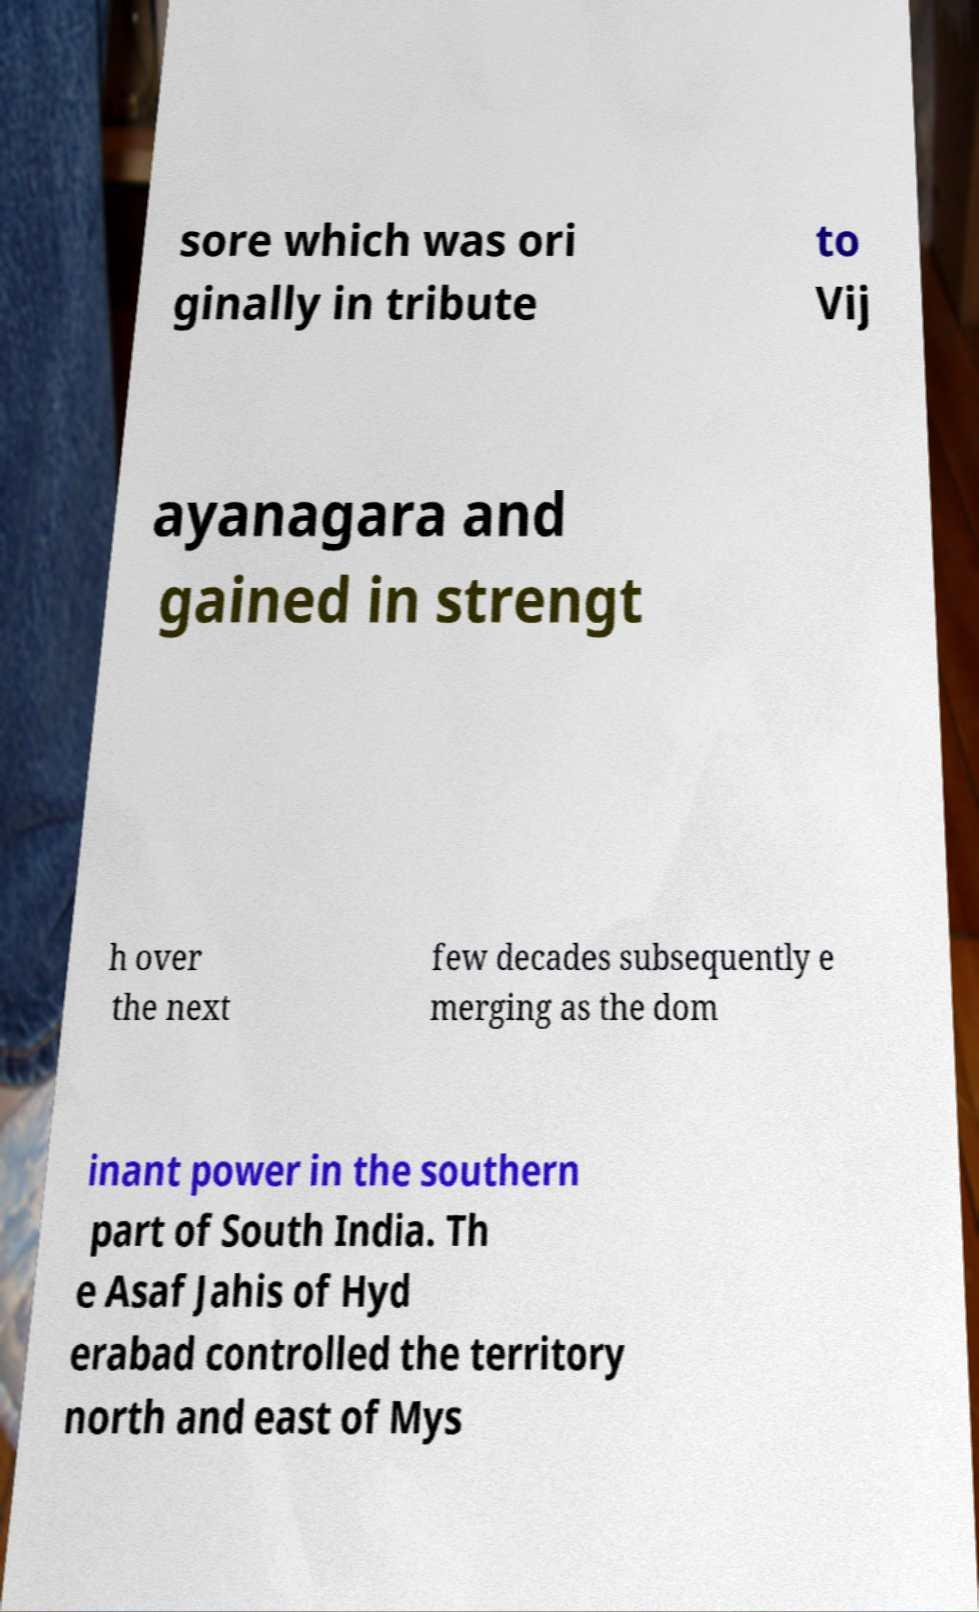Can you accurately transcribe the text from the provided image for me? sore which was ori ginally in tribute to Vij ayanagara and gained in strengt h over the next few decades subsequently e merging as the dom inant power in the southern part of South India. Th e Asaf Jahis of Hyd erabad controlled the territory north and east of Mys 